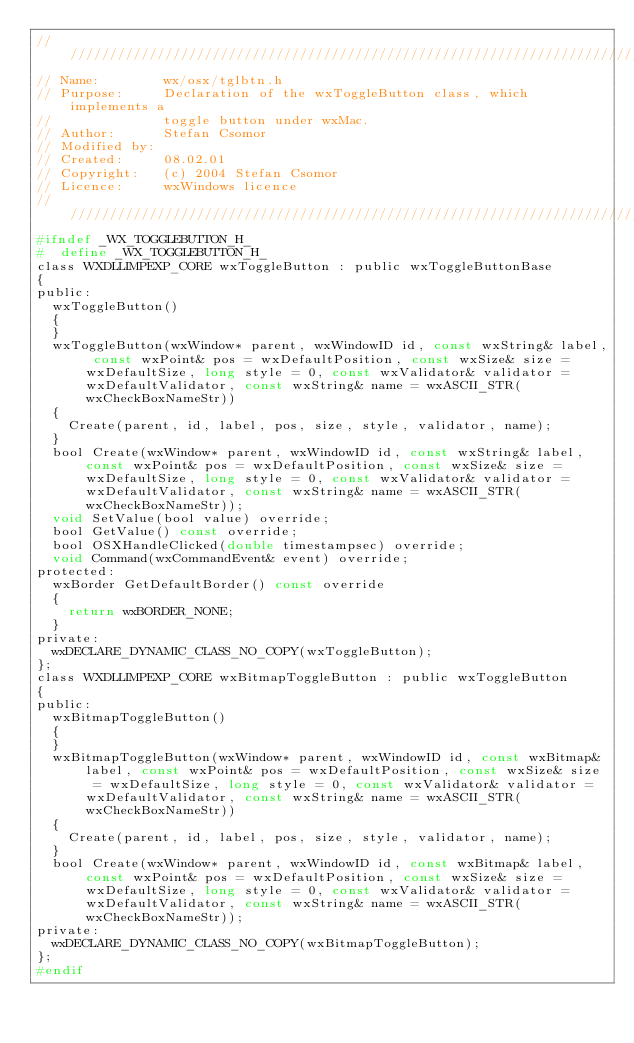Convert code to text. <code><loc_0><loc_0><loc_500><loc_500><_C_>/////////////////////////////////////////////////////////////////////////////
// Name:        wx/osx/tglbtn.h
// Purpose:     Declaration of the wxToggleButton class, which implements a
//              toggle button under wxMac.
// Author:      Stefan Csomor
// Modified by:
// Created:     08.02.01
// Copyright:   (c) 2004 Stefan Csomor
// Licence:     wxWindows licence
/////////////////////////////////////////////////////////////////////////////
#ifndef _WX_TOGGLEBUTTON_H_
#  define _WX_TOGGLEBUTTON_H_
class WXDLLIMPEXP_CORE wxToggleButton : public wxToggleButtonBase
{
public:
  wxToggleButton()
  {
  }
  wxToggleButton(wxWindow* parent, wxWindowID id, const wxString& label, const wxPoint& pos = wxDefaultPosition, const wxSize& size = wxDefaultSize, long style = 0, const wxValidator& validator = wxDefaultValidator, const wxString& name = wxASCII_STR(wxCheckBoxNameStr))
  {
    Create(parent, id, label, pos, size, style, validator, name);
  }
  bool Create(wxWindow* parent, wxWindowID id, const wxString& label, const wxPoint& pos = wxDefaultPosition, const wxSize& size = wxDefaultSize, long style = 0, const wxValidator& validator = wxDefaultValidator, const wxString& name = wxASCII_STR(wxCheckBoxNameStr));
  void SetValue(bool value) override;
  bool GetValue() const override;
  bool OSXHandleClicked(double timestampsec) override;
  void Command(wxCommandEvent& event) override;
protected:
  wxBorder GetDefaultBorder() const override
  {
    return wxBORDER_NONE;
  }
private:
  wxDECLARE_DYNAMIC_CLASS_NO_COPY(wxToggleButton);
};
class WXDLLIMPEXP_CORE wxBitmapToggleButton : public wxToggleButton
{
public:
  wxBitmapToggleButton()
  {
  }
  wxBitmapToggleButton(wxWindow* parent, wxWindowID id, const wxBitmap& label, const wxPoint& pos = wxDefaultPosition, const wxSize& size = wxDefaultSize, long style = 0, const wxValidator& validator = wxDefaultValidator, const wxString& name = wxASCII_STR(wxCheckBoxNameStr))
  {
    Create(parent, id, label, pos, size, style, validator, name);
  }
  bool Create(wxWindow* parent, wxWindowID id, const wxBitmap& label, const wxPoint& pos = wxDefaultPosition, const wxSize& size = wxDefaultSize, long style = 0, const wxValidator& validator = wxDefaultValidator, const wxString& name = wxASCII_STR(wxCheckBoxNameStr));
private:
  wxDECLARE_DYNAMIC_CLASS_NO_COPY(wxBitmapToggleButton);
};
#endif
</code> 